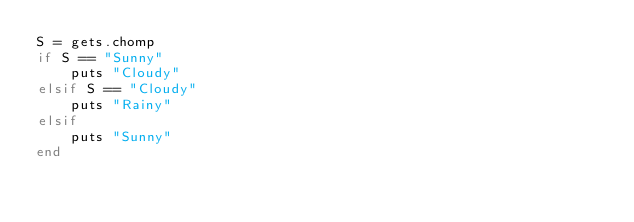Convert code to text. <code><loc_0><loc_0><loc_500><loc_500><_Ruby_>S = gets.chomp
if S == "Sunny"
    puts "Cloudy"
elsif S == "Cloudy"
    puts "Rainy"
elsif
    puts "Sunny"
end</code> 